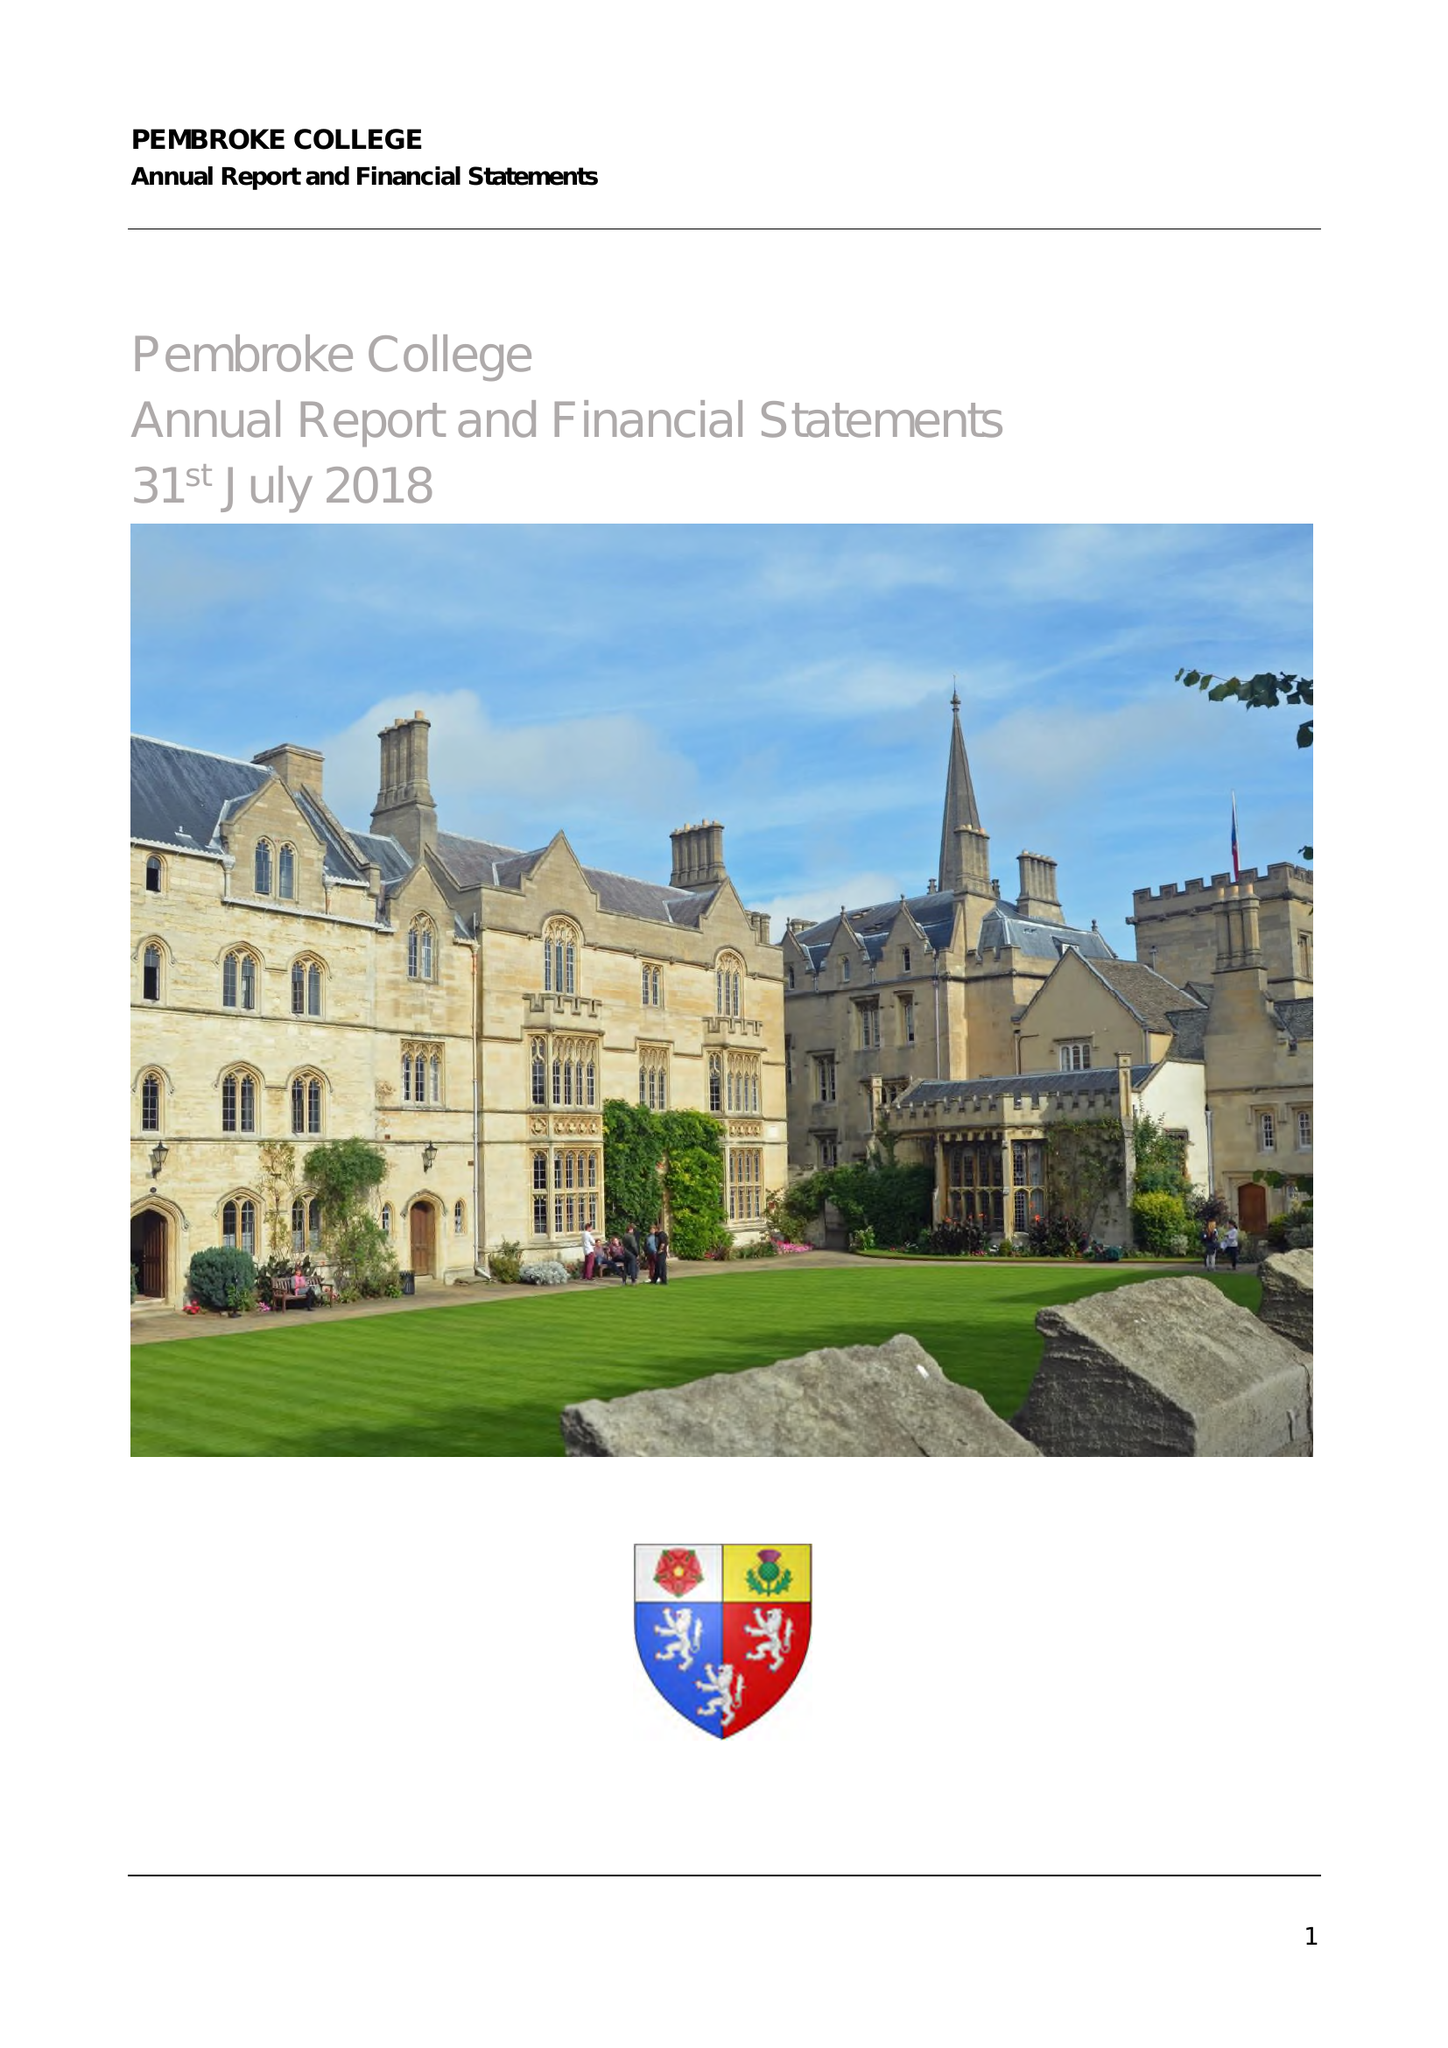What is the value for the charity_number?
Answer the question using a single word or phrase. 1137498 